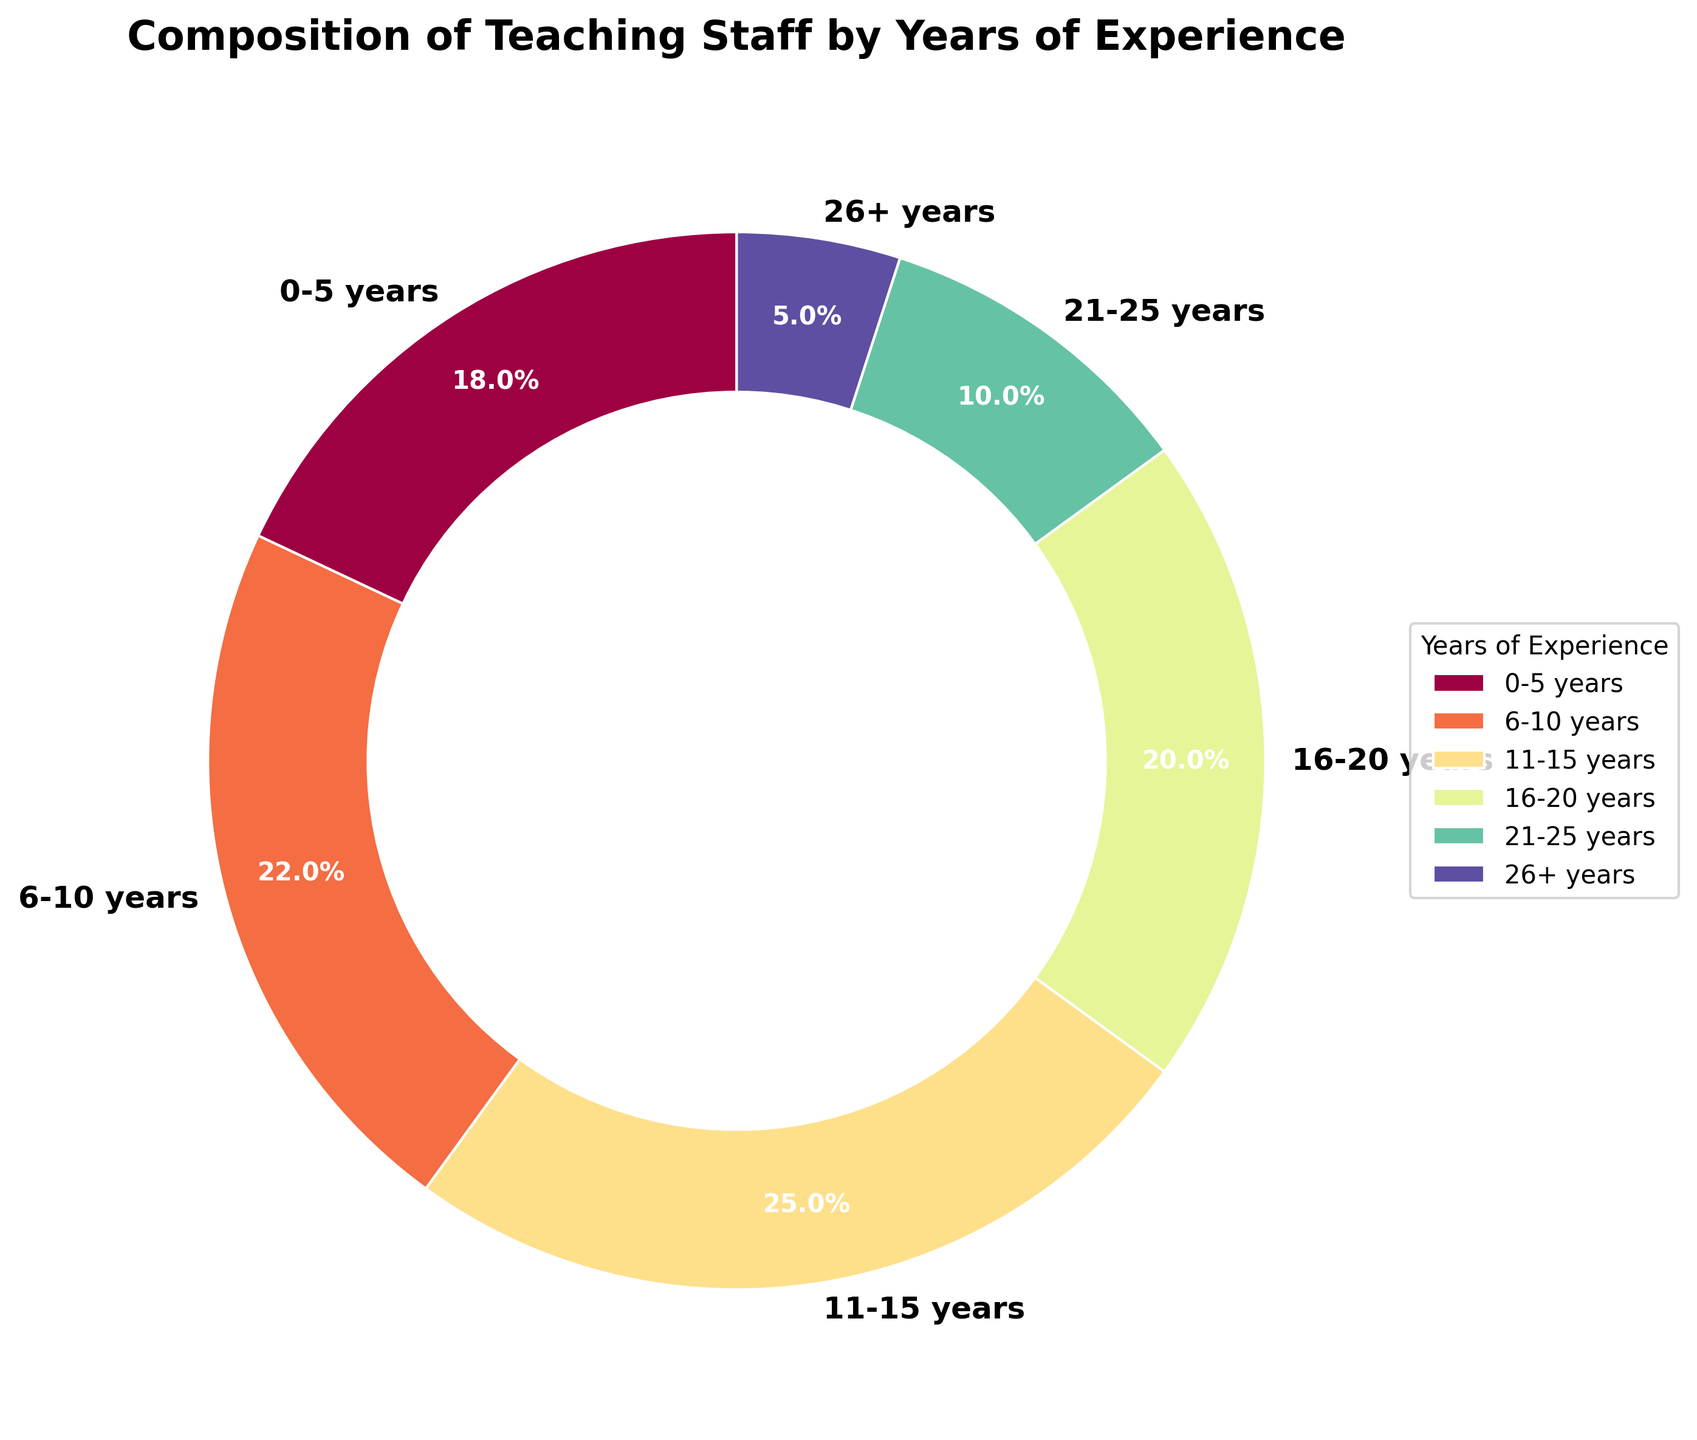Which group has the highest percentage of teaching staff? From the pie chart, the segment labeled "11-15 years" represents the largest portion. It has a percentage of 25%, which is higher than any other groups.
Answer: 11-15 years Which group has the lowest percentage of teaching staff? The segment labeled "26+ years" represents the smallest portion of the pie chart. It has a percentage of 5%, which is the lowest among all groups.
Answer: 26+ years What is the combined percentage of teaching staff with less than 11 years of experience? The groups "0-5 years" and "6-10 years" are the ones with less than 11 years of experience. Adding their percentages: 18% + 22% = 40%.
Answer: 40% Are there more teaching staff with over 20 years of experience or between 16-20 years of experience? The groups "21-25 years" and "26+ years" together have a percentage of 10% + 5% = 15%. The group "16-20 years" has a percentage of 20%. Therefore, the group "16-20 years" has more teaching staff.
Answer: 16-20 years What is the difference in percentage between the teaching staff with 0-5 years of experience and those with 6-10 years of experience? The group "6-10 years" has 22%, and "0-5 years" has 18%. The difference is 22% - 18% = 4%.
Answer: 4% What is the average percentage of teaching staff in each group? To find the average, sum all the percentages and divide by the number of groups: (18% + 22% + 25% + 20% + 10% + 5%) / 6 = 100% / 6 ≈ 16.67%.
Answer: 16.67% Which two groups combined make up half of the teaching staff? The groups "11-15 years" and "6-10 years" together make up 25% + 22% = 47%. By adding the group "0-5 years" with 18%, it overshoots 50%. However, the group "16-20 years" combined with "6-10 years" adds up to 20% + 22% = 42%. Therefore, "0-5 years" and "16-20 years" sum up to 18% + 20% = 38%, still less than half. Pairing "11-15 years" with "6-10 years" gives the closest answer without exceeding half.
Answer: 11-15 years and 6-10 years What is the total percentage of teaching staff with more than 15 years of experience? The groups "16-20 years", "21-25 years", and "26+ years" combined: 20% + 10% + 5% = 35%.
Answer: 35% Out of the "16-20 years" and "11-15 years" groups, which one has a lighter color? Visually comparing the two segments, the group "11-15 years" appears to have a slightly lighter shade compared to the "16-20 years" group.
Answer: 11-15 years 